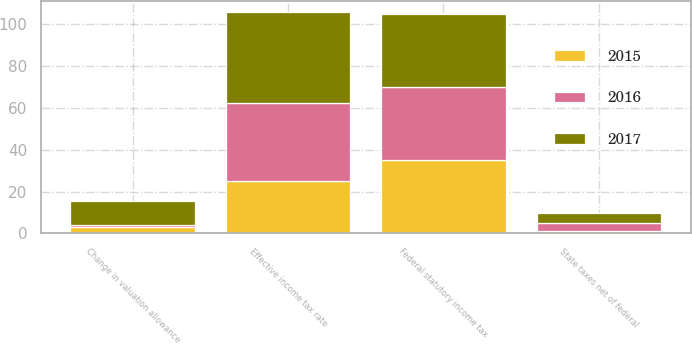Convert chart to OTSL. <chart><loc_0><loc_0><loc_500><loc_500><stacked_bar_chart><ecel><fcel>Federal statutory income tax<fcel>Change in valuation allowance<fcel>State taxes net of federal<fcel>Effective income tax rate<nl><fcel>2017<fcel>35<fcel>11.4<fcel>4.8<fcel>43.5<nl><fcel>2016<fcel>35<fcel>1<fcel>4<fcel>37.3<nl><fcel>2015<fcel>35<fcel>3.2<fcel>1.1<fcel>25.1<nl></chart> 